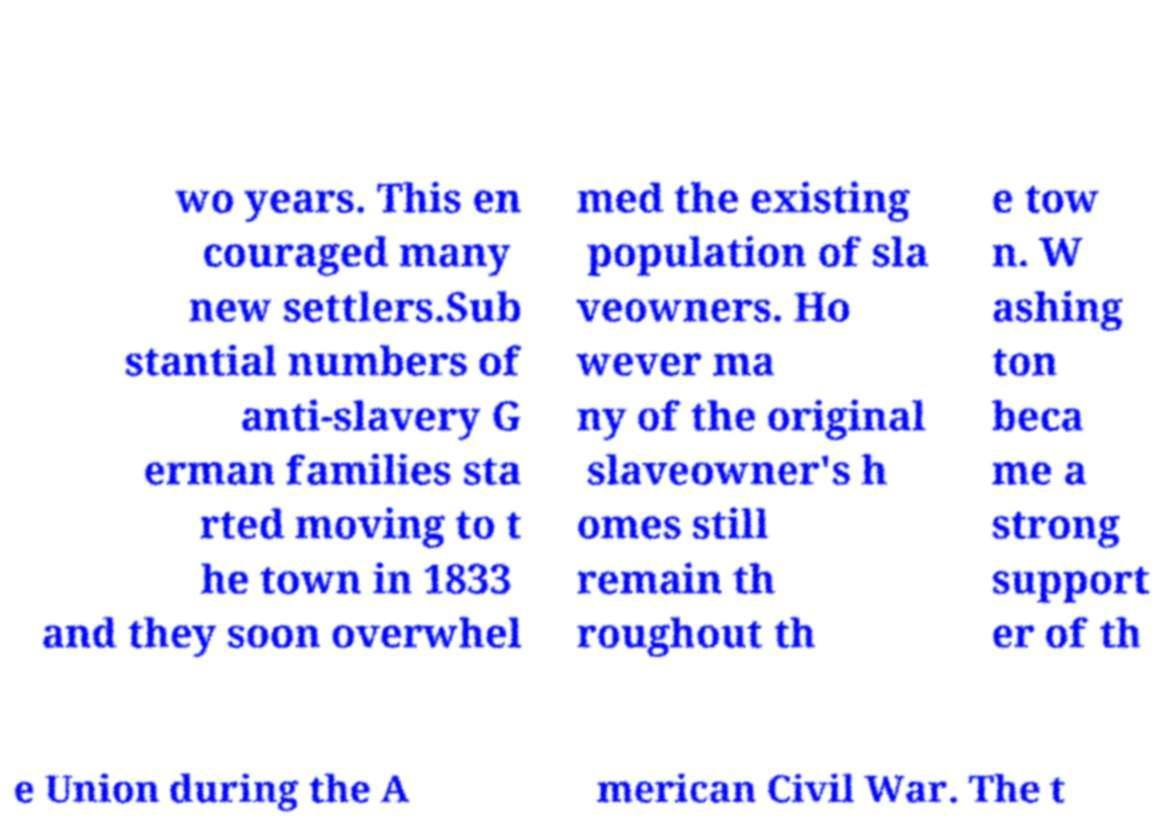Could you extract and type out the text from this image? wo years. This en couraged many new settlers.Sub stantial numbers of anti-slavery G erman families sta rted moving to t he town in 1833 and they soon overwhel med the existing population of sla veowners. Ho wever ma ny of the original slaveowner's h omes still remain th roughout th e tow n. W ashing ton beca me a strong support er of th e Union during the A merican Civil War. The t 